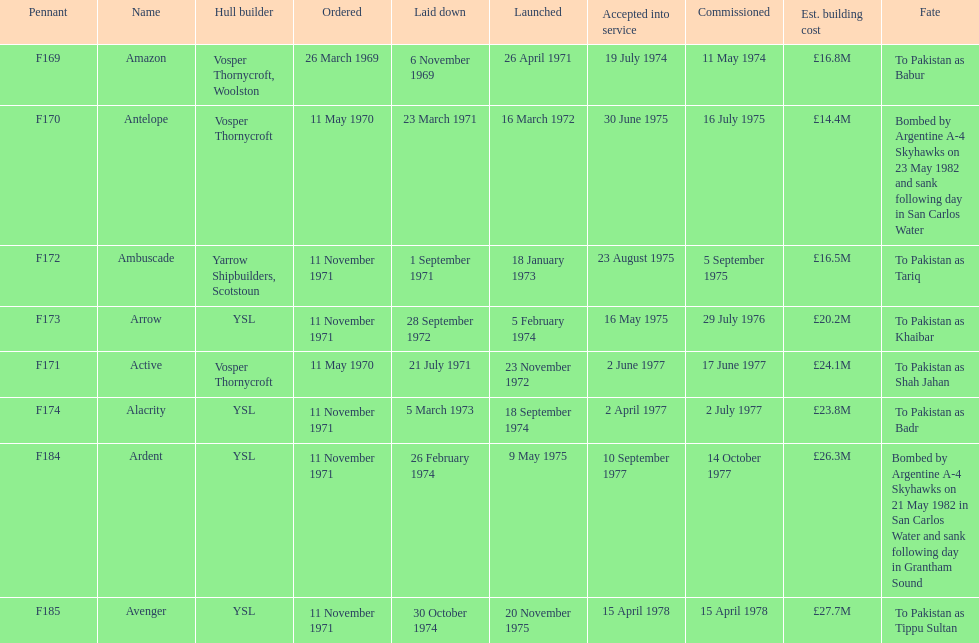Which vessel had the greatest estimated construction cost? Avenger. 